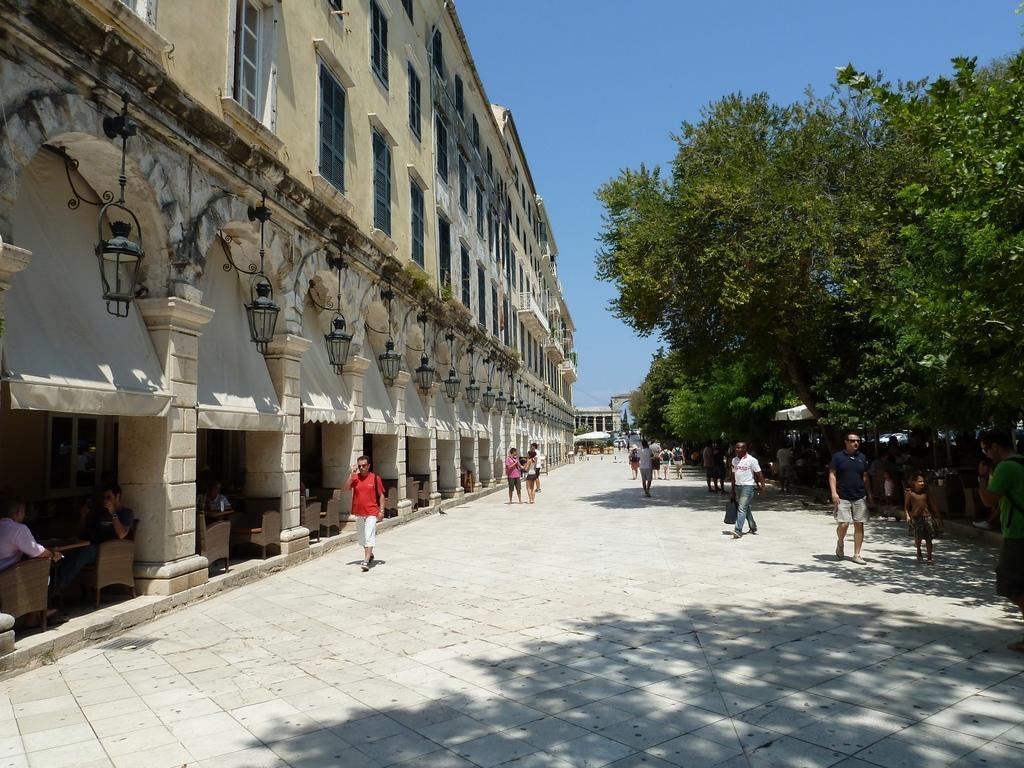Describe this image in one or two sentences. In this image, we can see some persons beside the building. There are some trees on the right side of the image. There is a sky in the top right of the image. 